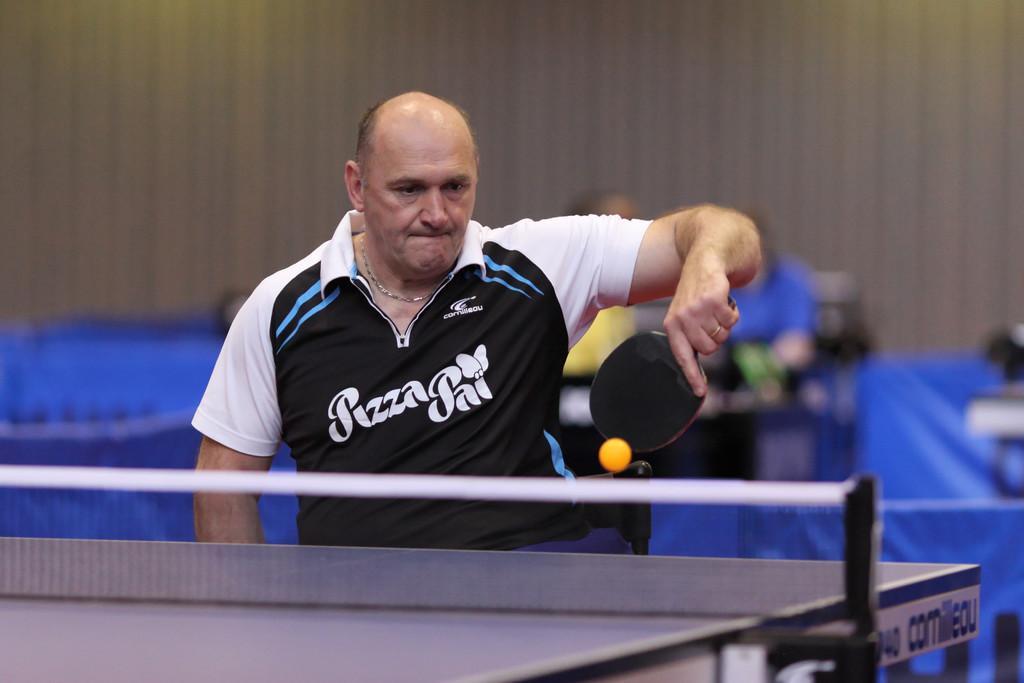How would you summarize this image in a sentence or two? As we can see in the image there is a man wearing black and white color t shirt and playing table tennis. The background is blurred. 